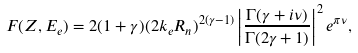Convert formula to latex. <formula><loc_0><loc_0><loc_500><loc_500>F ( Z , E _ { e } ) = 2 ( 1 + \gamma ) ( 2 k _ { e } R _ { n } ) ^ { 2 ( \gamma - 1 ) } \left | \frac { \Gamma ( \gamma + i \nu ) } { \Gamma ( 2 \gamma + 1 ) } \right | ^ { 2 } e ^ { \pi \nu } ,</formula> 